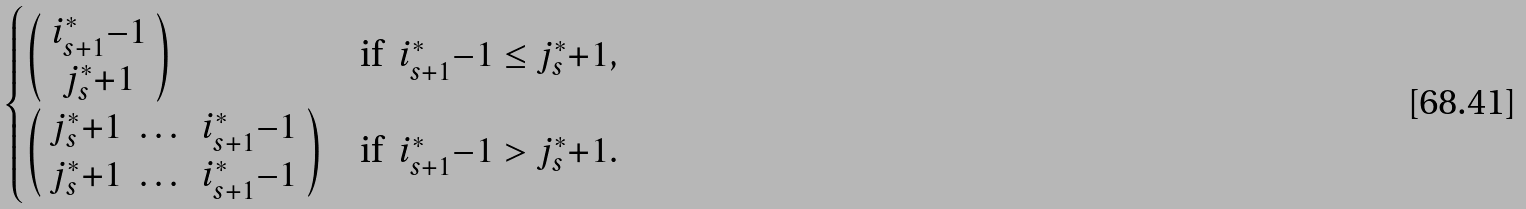Convert formula to latex. <formula><loc_0><loc_0><loc_500><loc_500>\begin{cases} \left ( \begin{array} { c } i _ { s + 1 } ^ { * } { - } 1 \\ j _ { s } ^ { * } { + } 1 \end{array} \right ) & \text {if } \ i _ { s + 1 } ^ { * } { - } 1 \leq j _ { s } ^ { * } { + } 1 , \\ \left ( \begin{array} { c c c } j _ { s } ^ { * } { + } 1 & \dots & i _ { s + 1 } ^ { * } { - } 1 \\ j _ { s } ^ { * } { + } 1 & \dots & i _ { s + 1 } ^ { * } { - } 1 \end{array} \right ) & \text {if } \ i _ { s + 1 } ^ { * } { - } 1 > j _ { s } ^ { * } { + } 1 . \end{cases}</formula> 